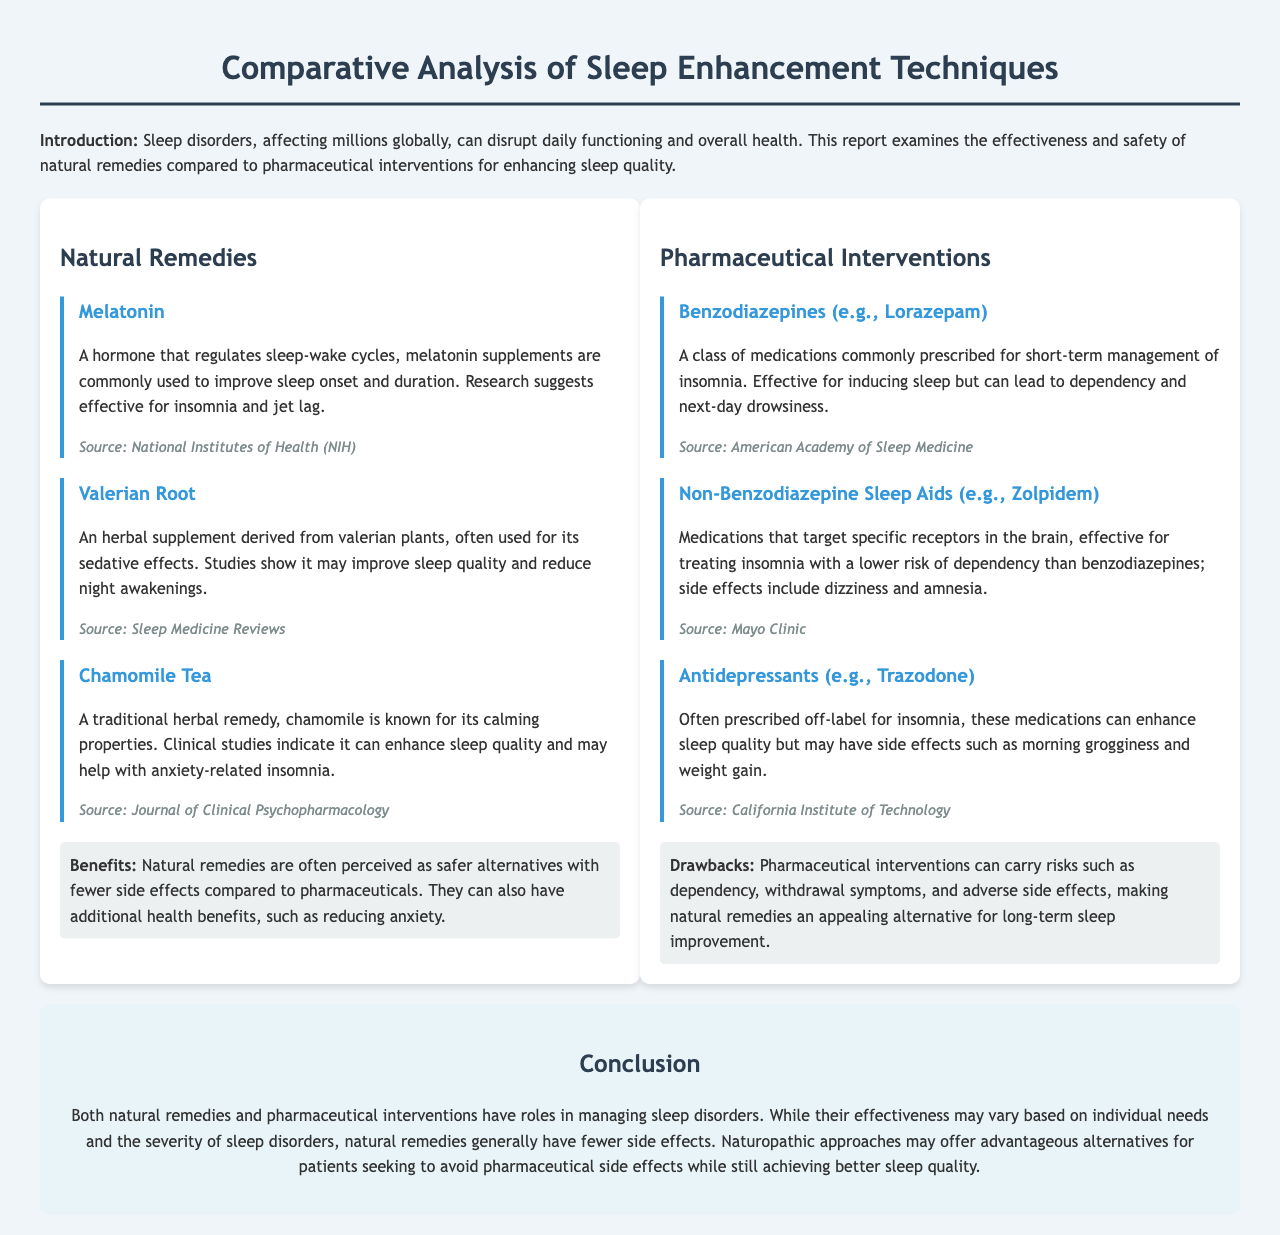what is the title of the report? The title can be found in the header of the document, which states the focus of the analysis.
Answer: Comparative Analysis of Sleep Enhancement Techniques how many natural remedies are discussed? The number of natural remedies is indicated by the list provided in the document.
Answer: 3 what is one benefit of natural remedies mentioned? The document highlights advantages of natural remedies, especially in comparison to pharmaceuticals.
Answer: Safer alternatives which pharmaceutical intervention is an antidepressant? The document lists various pharmaceutical interventions, specifying one as an antidepressant.
Answer: Trazodone what is a side effect of benzodiazepines? The document mentions specific risks associated with benzodiazepines, which are commonly prescribed medications.
Answer: Dependency which natural remedy is known for its calming properties? The document categorizes various natural remedies and highlights chamomile's specific properties.
Answer: Chamomile Tea what is a drawback of pharmaceutical interventions? The document outlines potential negative aspects of pharmaceutical interventions.
Answer: Dependency what hormone is commonly used to improve sleep? The use of this hormone is noted in the context of natural remedies within the document.
Answer: Melatonin how does the conclusion describe natural remedies in comparison to pharmaceuticals? The conclusion summarizes the findings related to the effectiveness of both approaches.
Answer: Fewer side effects 